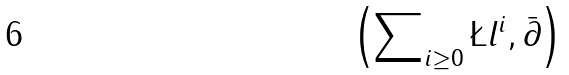Convert formula to latex. <formula><loc_0><loc_0><loc_500><loc_500>\left ( \sum \nolimits _ { i \geq 0 } \L l ^ { i } , \bar { \partial } \right )</formula> 